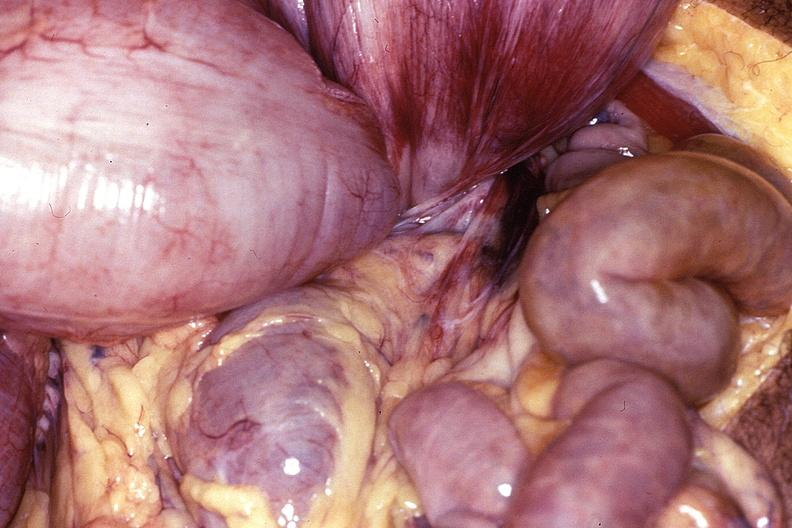does rheumatoid arthritis show intestine, volvulus?
Answer the question using a single word or phrase. No 